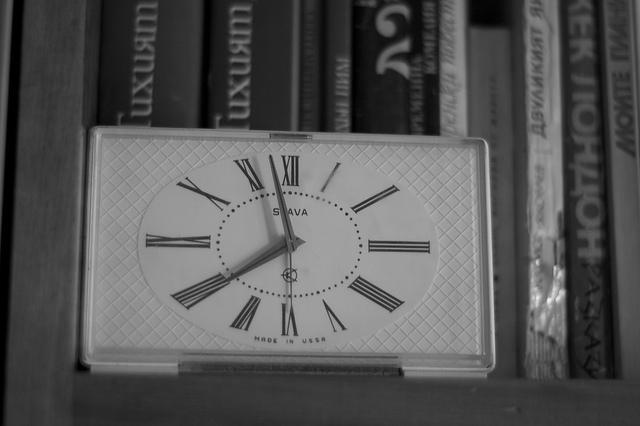How many books are in the picture?
Give a very brief answer. 11. 